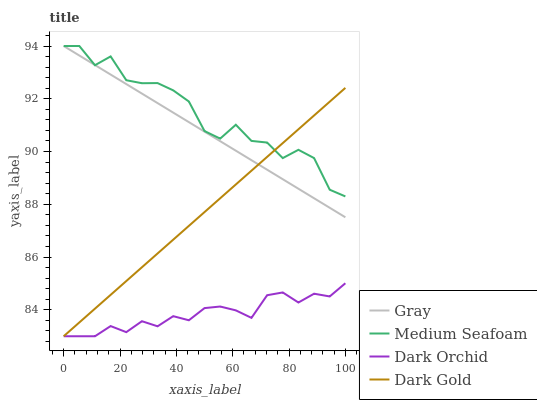Does Dark Orchid have the minimum area under the curve?
Answer yes or no. Yes. Does Medium Seafoam have the maximum area under the curve?
Answer yes or no. Yes. Does Medium Seafoam have the minimum area under the curve?
Answer yes or no. No. Does Dark Orchid have the maximum area under the curve?
Answer yes or no. No. Is Dark Gold the smoothest?
Answer yes or no. Yes. Is Medium Seafoam the roughest?
Answer yes or no. Yes. Is Dark Orchid the smoothest?
Answer yes or no. No. Is Dark Orchid the roughest?
Answer yes or no. No. Does Dark Orchid have the lowest value?
Answer yes or no. Yes. Does Medium Seafoam have the lowest value?
Answer yes or no. No. Does Medium Seafoam have the highest value?
Answer yes or no. Yes. Does Dark Orchid have the highest value?
Answer yes or no. No. Is Dark Orchid less than Medium Seafoam?
Answer yes or no. Yes. Is Gray greater than Dark Orchid?
Answer yes or no. Yes. Does Dark Orchid intersect Dark Gold?
Answer yes or no. Yes. Is Dark Orchid less than Dark Gold?
Answer yes or no. No. Is Dark Orchid greater than Dark Gold?
Answer yes or no. No. Does Dark Orchid intersect Medium Seafoam?
Answer yes or no. No. 